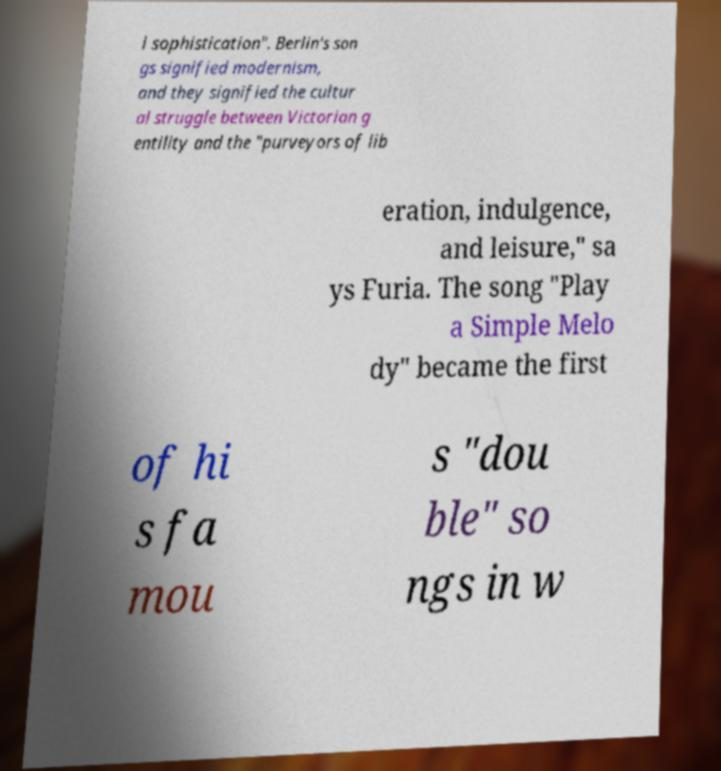There's text embedded in this image that I need extracted. Can you transcribe it verbatim? l sophistication". Berlin's son gs signified modernism, and they signified the cultur al struggle between Victorian g entility and the "purveyors of lib eration, indulgence, and leisure," sa ys Furia. The song "Play a Simple Melo dy" became the first of hi s fa mou s "dou ble" so ngs in w 